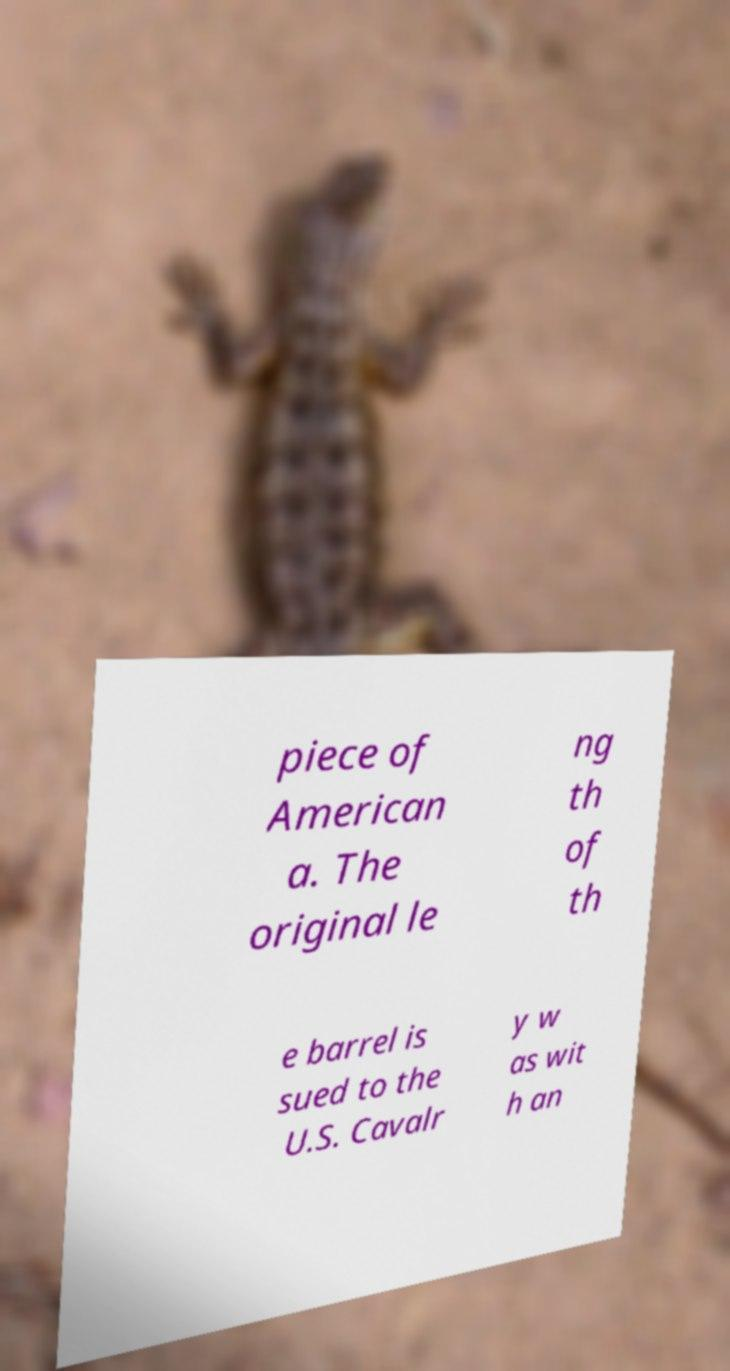Could you extract and type out the text from this image? piece of American a. The original le ng th of th e barrel is sued to the U.S. Cavalr y w as wit h an 